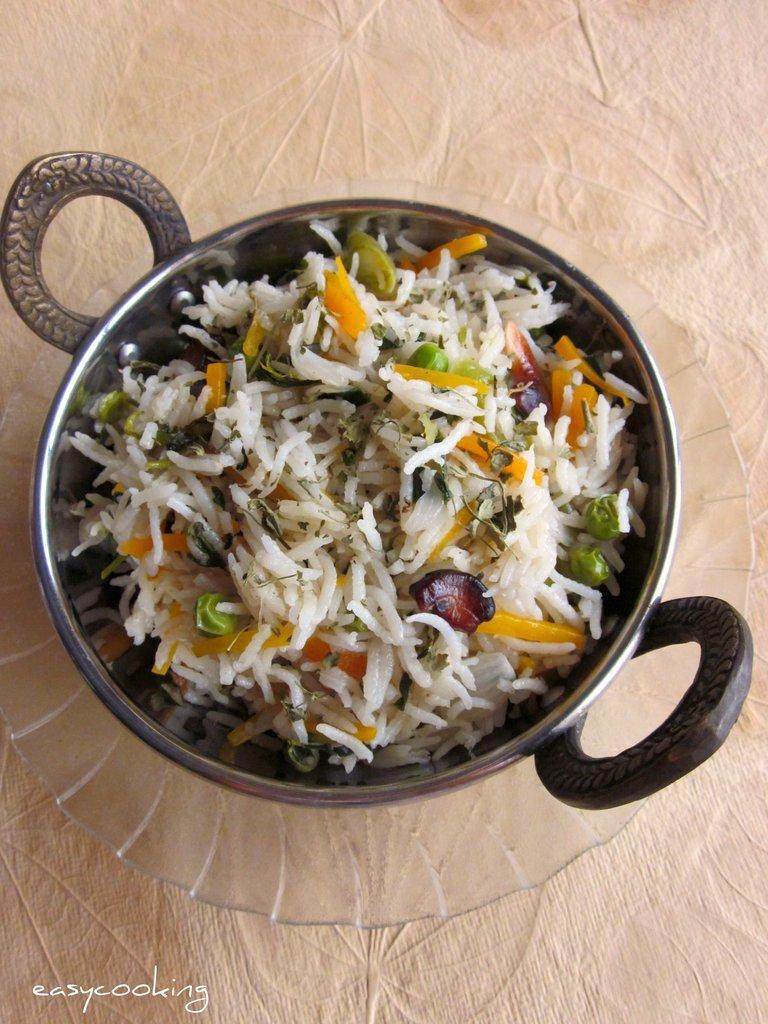Describe this image in one or two sentences. In this picture, we see a pan containing fried rice is placed in the glass bowl and this bowl is placed on the table. 